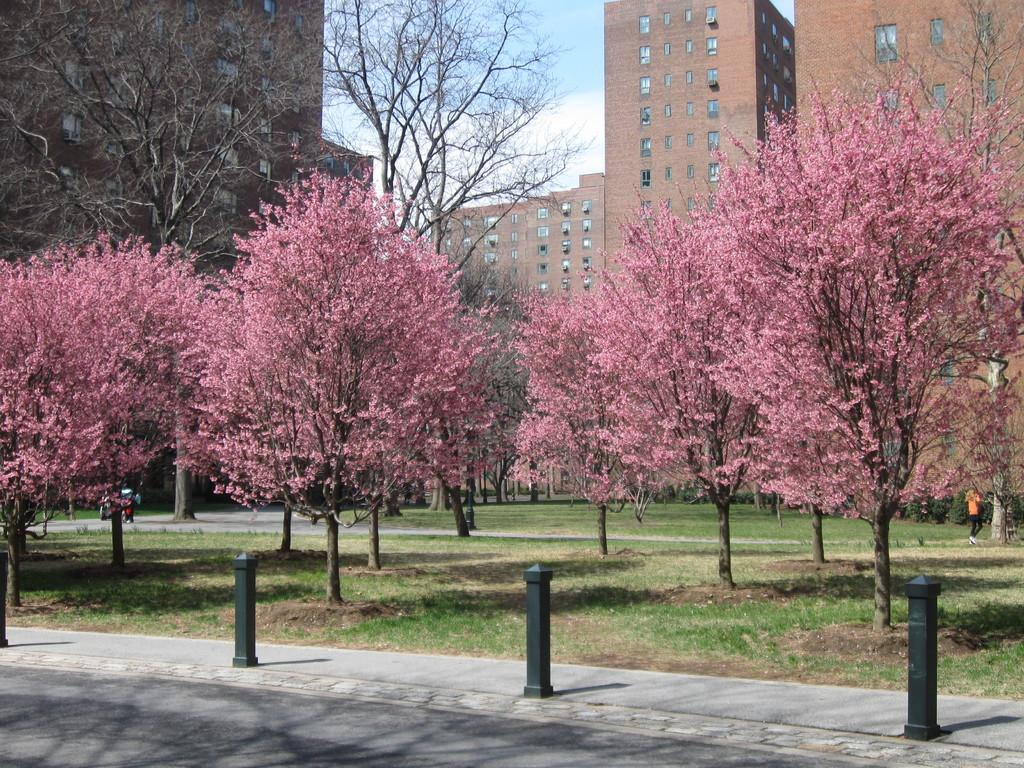What type of vegetation can be seen in the image? There are trees in the image. What type of structures are present in the image? There are buildings in the image. What is the ground covered with in the image? There is grass visible in the image. What part of the natural environment is visible in the image? The sky is visible in the image. What type of furniture can be seen in the image? There is no furniture present in the image; it features trees, buildings, grass, and the sky. Who is the governor in the image? There is no reference to a governor in the image. 